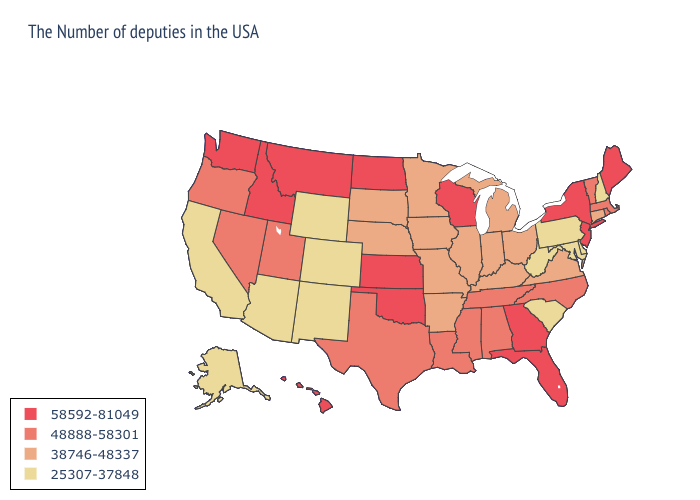Which states hav the highest value in the Northeast?
Keep it brief. Maine, New York, New Jersey. Name the states that have a value in the range 25307-37848?
Write a very short answer. New Hampshire, Delaware, Maryland, Pennsylvania, South Carolina, West Virginia, Wyoming, Colorado, New Mexico, Arizona, California, Alaska. What is the highest value in the West ?
Answer briefly. 58592-81049. Does New Jersey have the lowest value in the USA?
Keep it brief. No. Does the map have missing data?
Give a very brief answer. No. Does the first symbol in the legend represent the smallest category?
Short answer required. No. Which states have the lowest value in the USA?
Quick response, please. New Hampshire, Delaware, Maryland, Pennsylvania, South Carolina, West Virginia, Wyoming, Colorado, New Mexico, Arizona, California, Alaska. Among the states that border Pennsylvania , which have the lowest value?
Quick response, please. Delaware, Maryland, West Virginia. What is the lowest value in the West?
Answer briefly. 25307-37848. What is the highest value in states that border Nebraska?
Write a very short answer. 58592-81049. What is the lowest value in the West?
Give a very brief answer. 25307-37848. Is the legend a continuous bar?
Keep it brief. No. Among the states that border Alabama , which have the lowest value?
Write a very short answer. Tennessee, Mississippi. Does Pennsylvania have a lower value than Montana?
Keep it brief. Yes. Name the states that have a value in the range 48888-58301?
Keep it brief. Massachusetts, Rhode Island, Vermont, North Carolina, Alabama, Tennessee, Mississippi, Louisiana, Texas, Utah, Nevada, Oregon. 